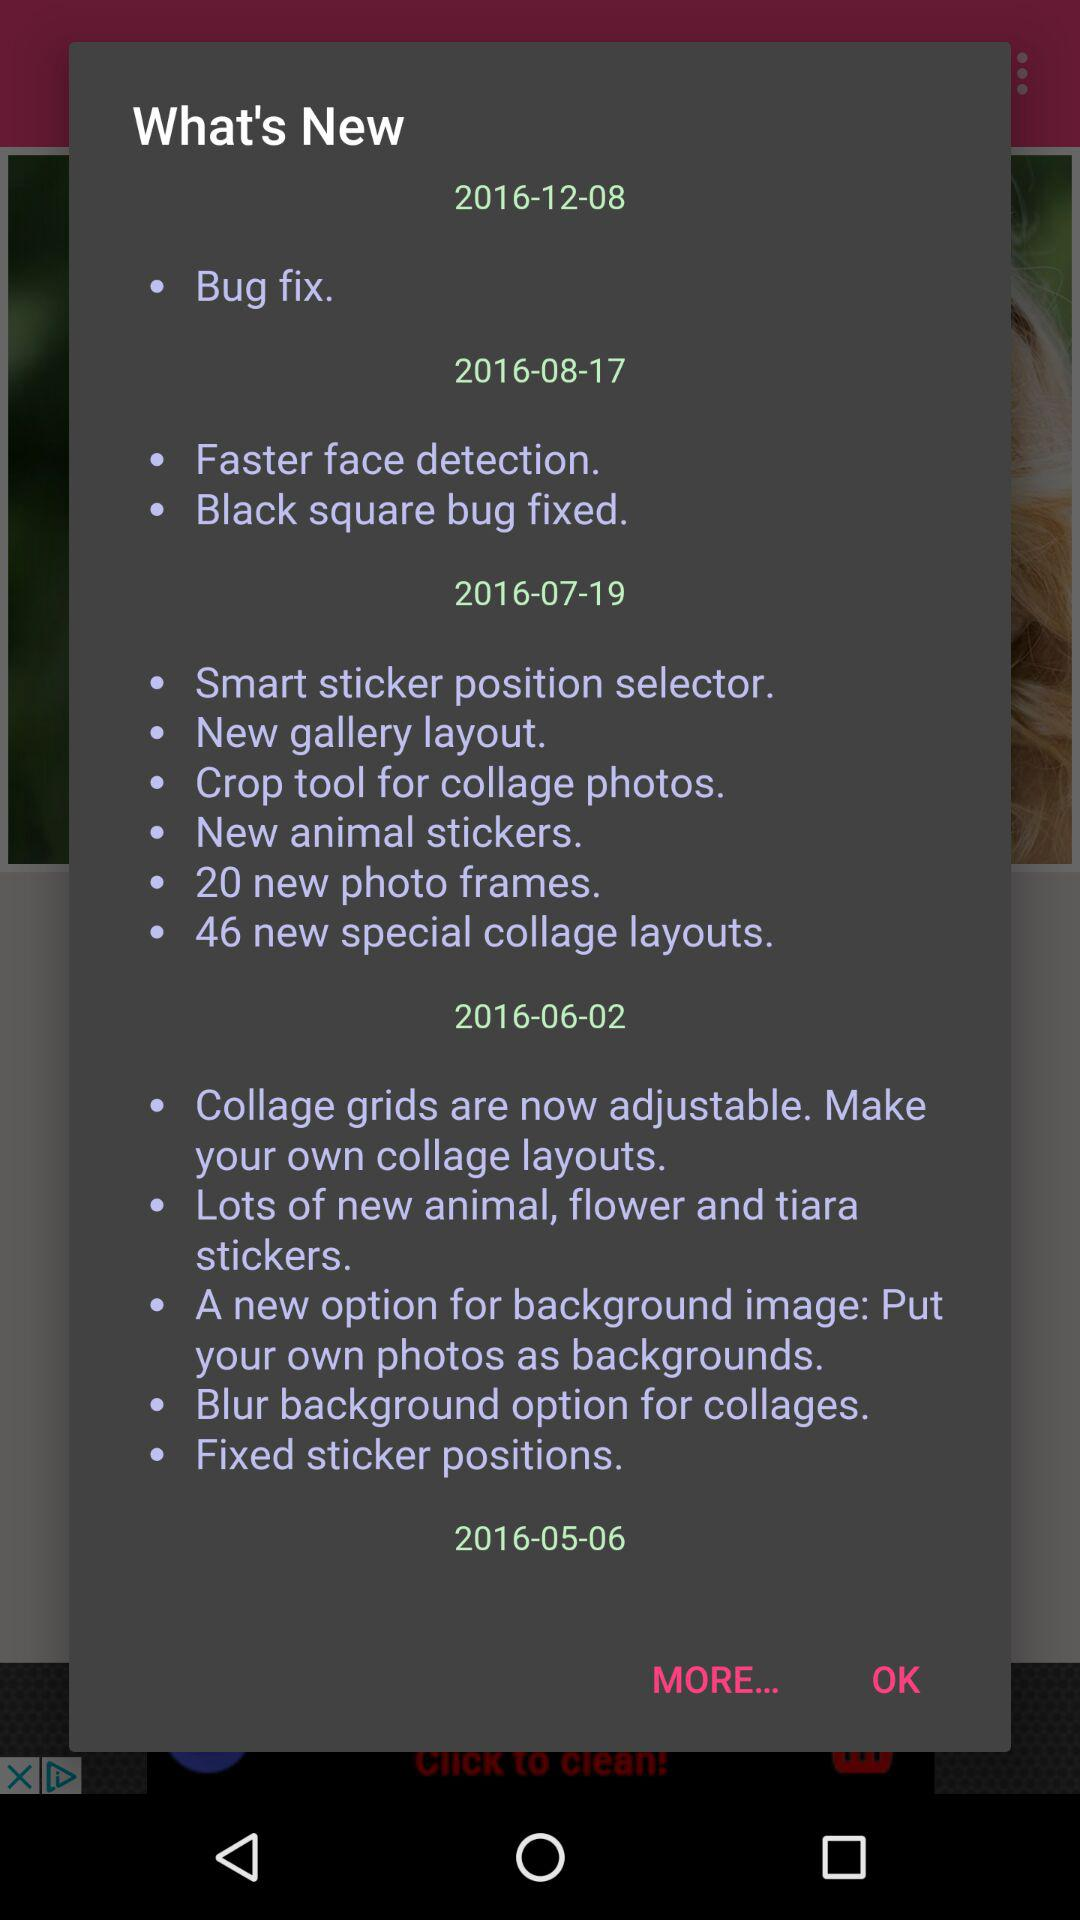What is the new information on the date 2016-07-19? The new information are "Smart sticker position selector", "New gallery layout", "Crop tool for collage photos", "New animal stickers", "20 new photo frames" and "46 new special collage layouts". 